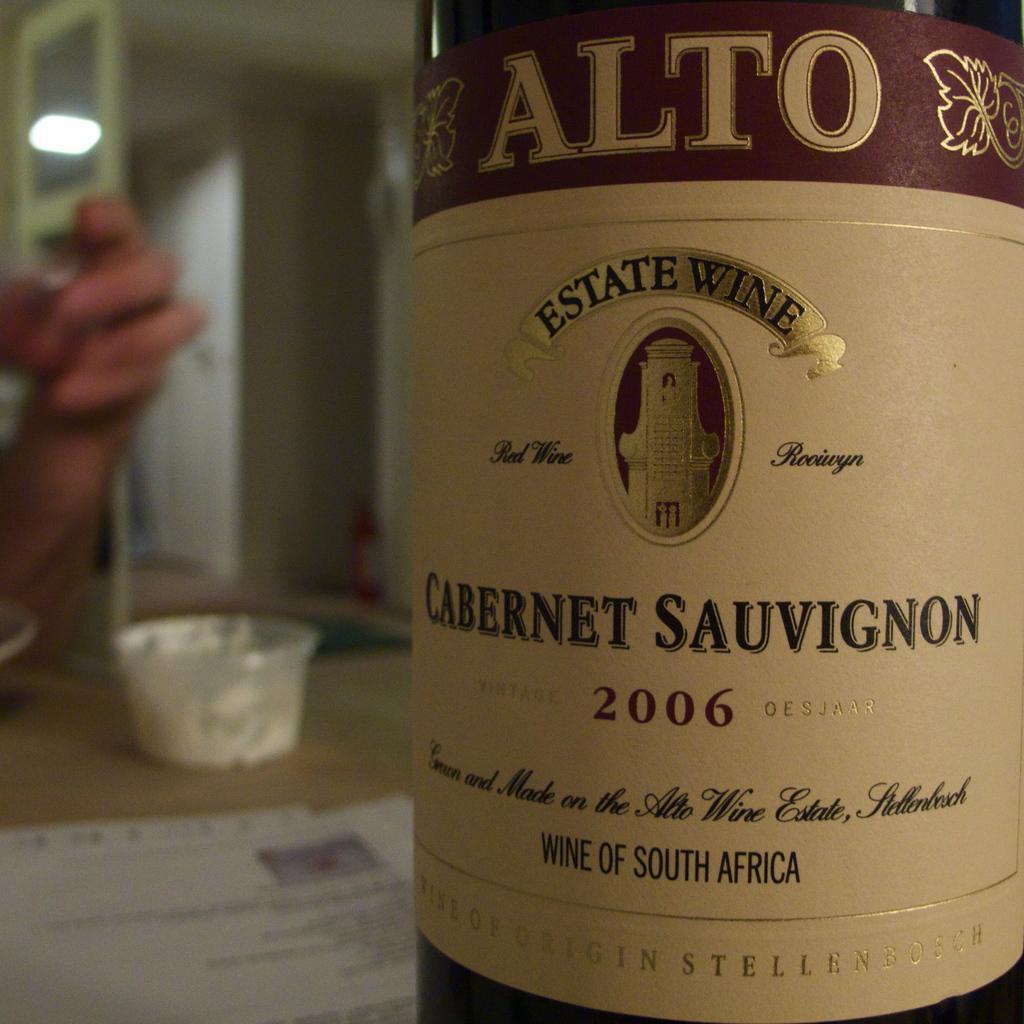How would you summarize this image in a sentence or two? In this image I can see the bottle, cup and the paper on the cream color surface and I can also see the person's hand and I can see the blurred background. 